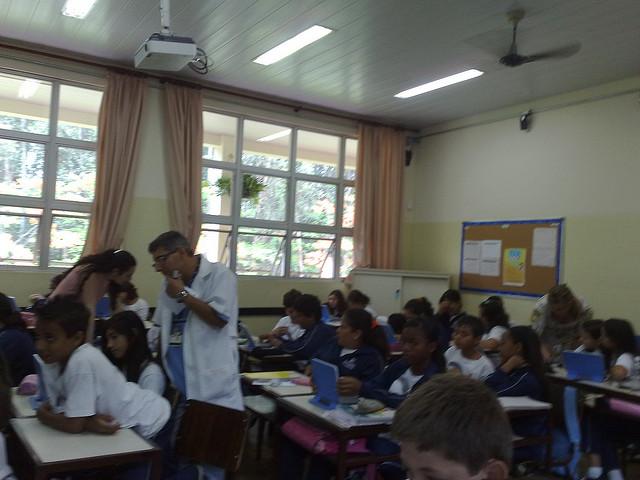What is hanging from the ceiling?
Quick response, please. Fan. What is the man in the center aisle doing?
Write a very short answer. Teaching. Why are the windows open in the classroom?
Write a very short answer. Its hot. Are the people inside a tent?
Quick response, please. No. How many people have red shirts on?
Answer briefly. 0. Where does this scene likely take place?
Concise answer only. School. Does this appear to be a school?
Write a very short answer. Yes. Was this photo taken at a high school?
Write a very short answer. No. Are the lights on?
Give a very brief answer. Yes. How many kids are in the picture?
Write a very short answer. 17. Which person is probably speaking?
Give a very brief answer. Teacher. Is this an airport?
Concise answer only. No. 